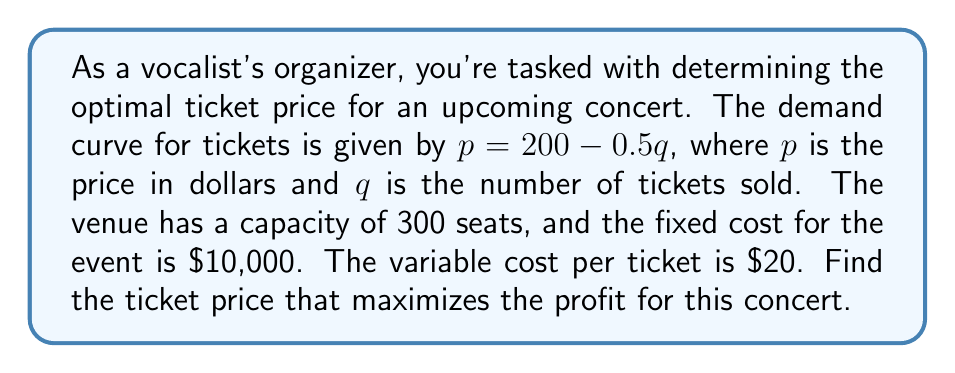What is the answer to this math problem? 1) First, we need to express the revenue (R) and cost (C) functions:
   Revenue: $R = pq = (200 - 0.5q)q = 200q - 0.5q^2$
   Cost: $C = 10000 + 20q$

2) The profit function (P) is revenue minus cost:
   $P = R - C = (200q - 0.5q^2) - (10000 + 20q) = -0.5q^2 + 180q - 10000$

3) To find the maximum profit, we need to find where the derivative of P with respect to q is zero:
   $$\frac{dP}{dq} = -q + 180$$

4) Set this equal to zero and solve for q:
   $-q + 180 = 0$
   $q = 180$

5) Check the second derivative to confirm this is a maximum:
   $$\frac{d^2P}{dq^2} = -1 < 0$$
   This confirms we have a maximum.

6) Now, we need to check if this quantity is within the venue's capacity:
   180 < 300, so this solution is valid.

7) To find the optimal price, we substitute q = 180 into the demand equation:
   $p = 200 - 0.5(180) = 200 - 90 = 110$

Therefore, the optimal ticket price is $110.
Answer: $110 